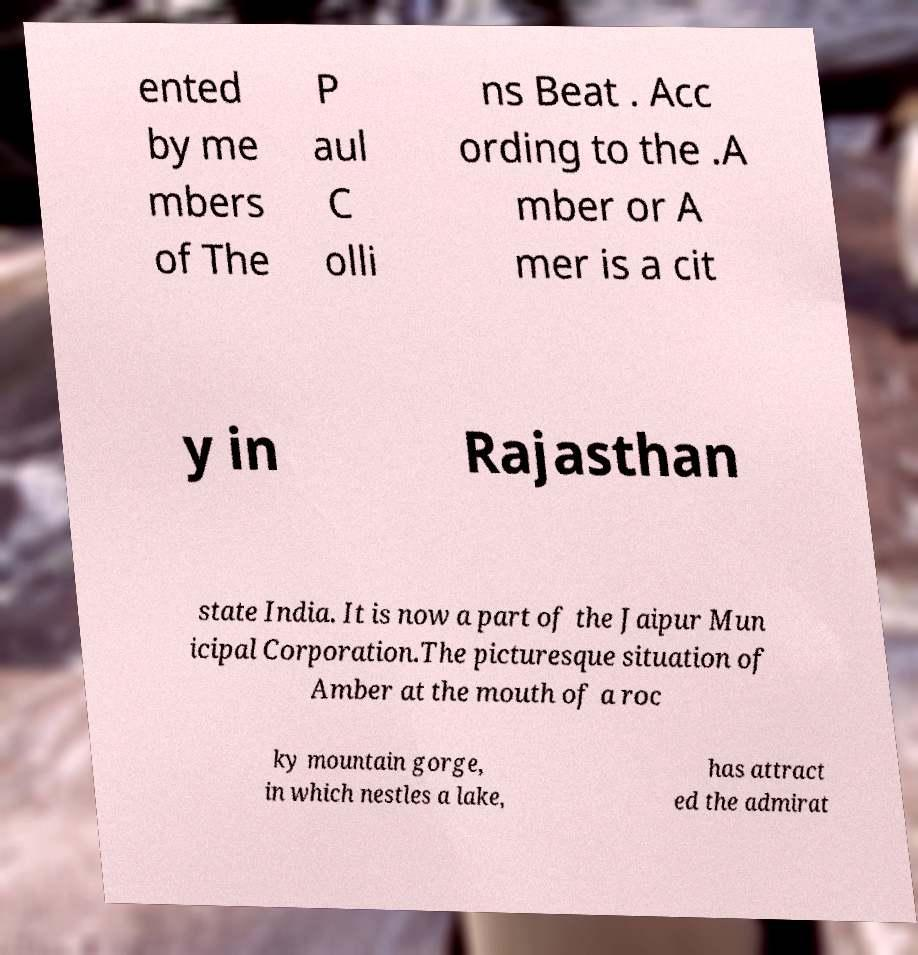Please identify and transcribe the text found in this image. ented by me mbers of The P aul C olli ns Beat . Acc ording to the .A mber or A mer is a cit y in Rajasthan state India. It is now a part of the Jaipur Mun icipal Corporation.The picturesque situation of Amber at the mouth of a roc ky mountain gorge, in which nestles a lake, has attract ed the admirat 